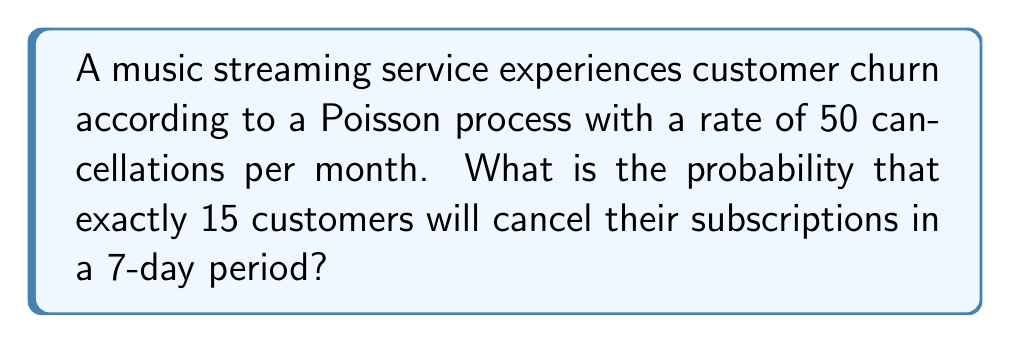Can you answer this question? To solve this problem, we'll follow these steps:

1. Convert the monthly rate to a daily rate:
   $\lambda_{daily} = \frac{50}{30} \approx 1.67$ cancellations per day

2. Calculate the rate for a 7-day period:
   $\lambda_7 = 1.67 \times 7 \approx 11.67$ cancellations per 7 days

3. Use the Poisson probability mass function:
   $$P(X = k) = \frac{e^{-\lambda}\lambda^k}{k!}$$
   
   Where:
   $\lambda = 11.67$ (rate for 7 days)
   $k = 15$ (number of cancellations we're interested in)

4. Plug in the values:
   $$P(X = 15) = \frac{e^{-11.67}(11.67)^{15}}{15!}$$

5. Calculate:
   $$P(X = 15) \approx \frac{2.318 \times 10^{-6} \times 1.766 \times 10^{16}}{1.307 \times 10^{12}}$$
   $$P(X = 15) \approx 0.0312$$

Thus, the probability of exactly 15 cancellations in a 7-day period is approximately 0.0312 or 3.12%.
Answer: 0.0312 